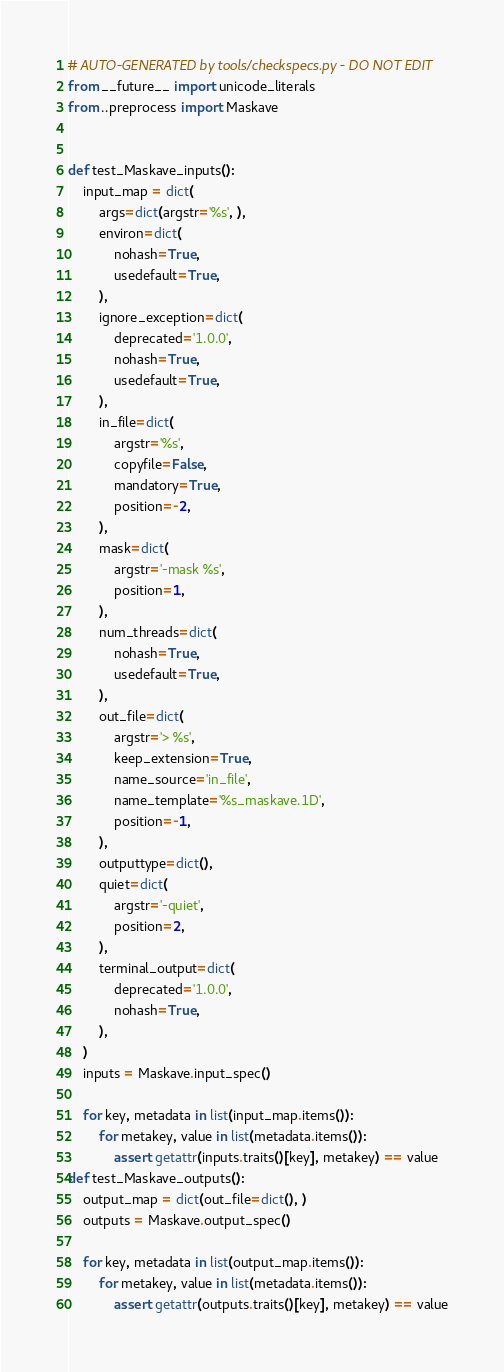<code> <loc_0><loc_0><loc_500><loc_500><_Python_># AUTO-GENERATED by tools/checkspecs.py - DO NOT EDIT
from __future__ import unicode_literals
from ..preprocess import Maskave


def test_Maskave_inputs():
    input_map = dict(
        args=dict(argstr='%s', ),
        environ=dict(
            nohash=True,
            usedefault=True,
        ),
        ignore_exception=dict(
            deprecated='1.0.0',
            nohash=True,
            usedefault=True,
        ),
        in_file=dict(
            argstr='%s',
            copyfile=False,
            mandatory=True,
            position=-2,
        ),
        mask=dict(
            argstr='-mask %s',
            position=1,
        ),
        num_threads=dict(
            nohash=True,
            usedefault=True,
        ),
        out_file=dict(
            argstr='> %s',
            keep_extension=True,
            name_source='in_file',
            name_template='%s_maskave.1D',
            position=-1,
        ),
        outputtype=dict(),
        quiet=dict(
            argstr='-quiet',
            position=2,
        ),
        terminal_output=dict(
            deprecated='1.0.0',
            nohash=True,
        ),
    )
    inputs = Maskave.input_spec()

    for key, metadata in list(input_map.items()):
        for metakey, value in list(metadata.items()):
            assert getattr(inputs.traits()[key], metakey) == value
def test_Maskave_outputs():
    output_map = dict(out_file=dict(), )
    outputs = Maskave.output_spec()

    for key, metadata in list(output_map.items()):
        for metakey, value in list(metadata.items()):
            assert getattr(outputs.traits()[key], metakey) == value
</code> 